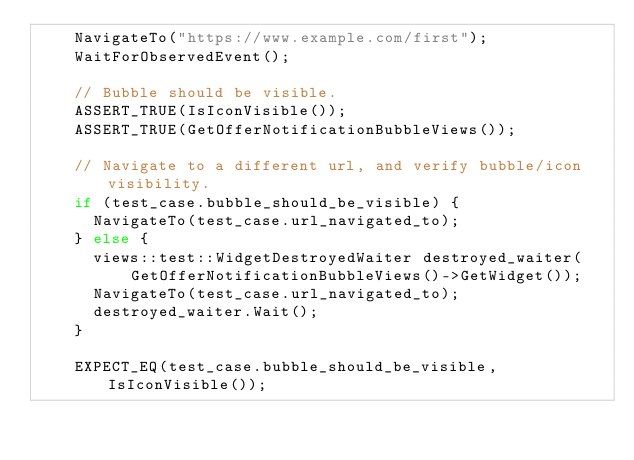Convert code to text. <code><loc_0><loc_0><loc_500><loc_500><_C++_>    NavigateTo("https://www.example.com/first");
    WaitForObservedEvent();

    // Bubble should be visible.
    ASSERT_TRUE(IsIconVisible());
    ASSERT_TRUE(GetOfferNotificationBubbleViews());

    // Navigate to a different url, and verify bubble/icon visibility.
    if (test_case.bubble_should_be_visible) {
      NavigateTo(test_case.url_navigated_to);
    } else {
      views::test::WidgetDestroyedWaiter destroyed_waiter(
          GetOfferNotificationBubbleViews()->GetWidget());
      NavigateTo(test_case.url_navigated_to);
      destroyed_waiter.Wait();
    }

    EXPECT_EQ(test_case.bubble_should_be_visible, IsIconVisible());</code> 